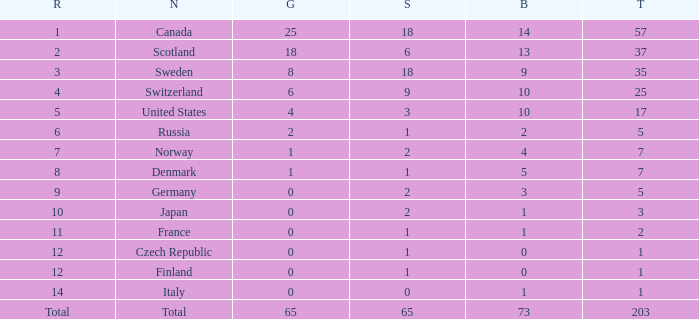What is the lowest total when the rank is 14 and the gold medals is larger than 0? None. 